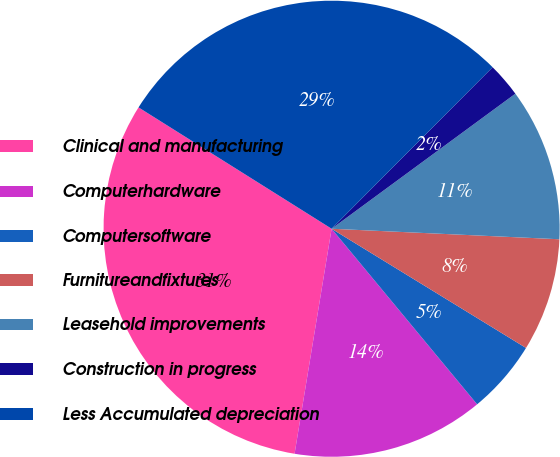<chart> <loc_0><loc_0><loc_500><loc_500><pie_chart><fcel>Clinical and manufacturing<fcel>Computerhardware<fcel>Computersoftware<fcel>Furnitureandfixtures<fcel>Leasehold improvements<fcel>Construction in progress<fcel>Less Accumulated depreciation<nl><fcel>31.33%<fcel>13.61%<fcel>5.23%<fcel>8.02%<fcel>10.82%<fcel>2.44%<fcel>28.54%<nl></chart> 